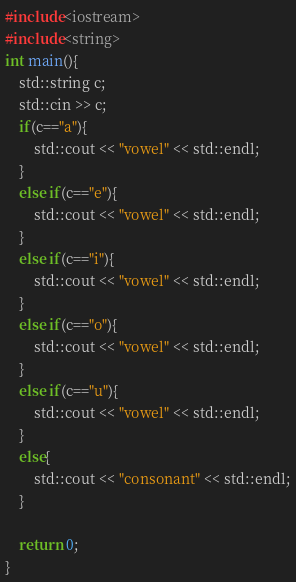<code> <loc_0><loc_0><loc_500><loc_500><_C++_>#include<iostream>
#include<string>
int main(){
    std::string c;
    std::cin >> c;
    if(c=="a"){
        std::cout << "vowel" << std::endl;
    }
    else if(c=="e"){
        std::cout << "vowel" << std::endl;
    }
    else if(c=="i"){
        std::cout << "vowel" << std::endl;
    }
    else if(c=="o"){
        std::cout << "vowel" << std::endl;
    }
    else if(c=="u"){
        std::cout << "vowel" << std::endl;
    }
    else{
        std::cout << "consonant" << std::endl;
    }
    
    return 0;
}</code> 